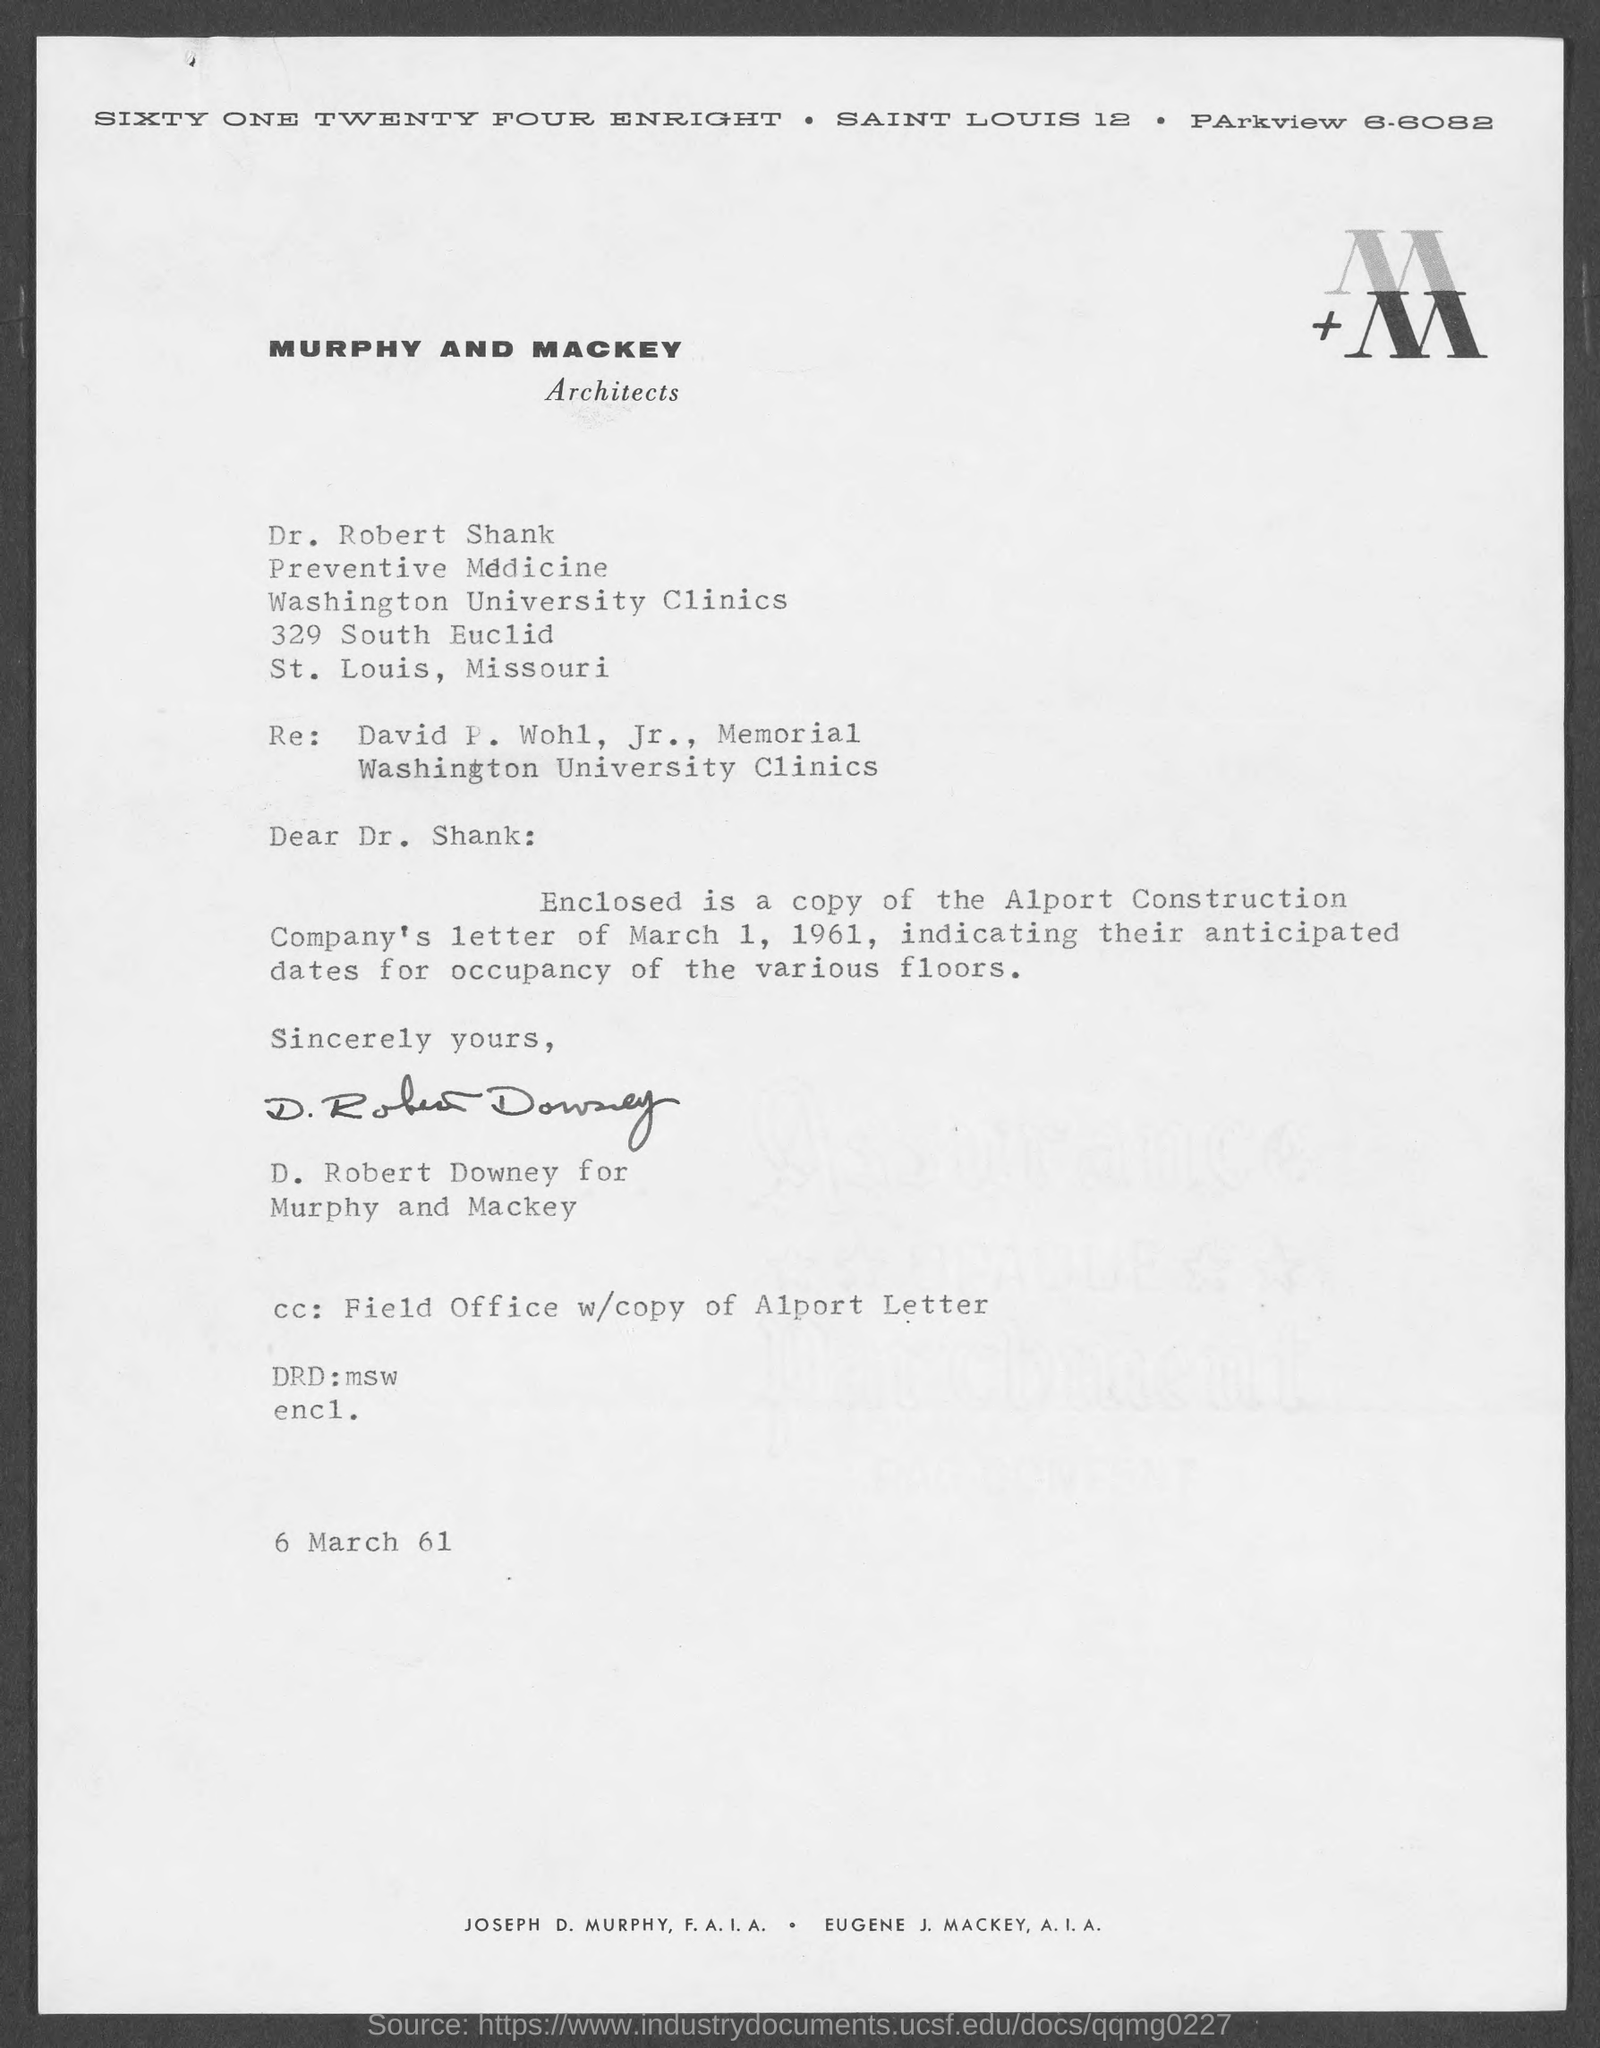Who is the Memorandum Address to ?
Offer a very short reply. Dr. Robert Shank. Who is written this letter ?
Make the answer very short. D. Robert Downey. What is the date mentioned in the bottom of the document ?
Your answer should be compact. 6 March 61. What is written in the DRD Field ?
Provide a succinct answer. Msw. 